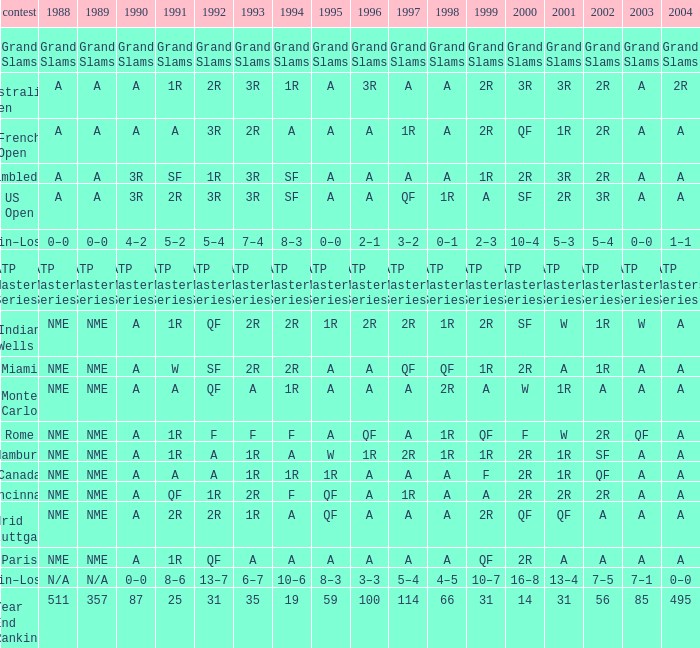What shows for 2002 when the 1991 is w? 1R. 